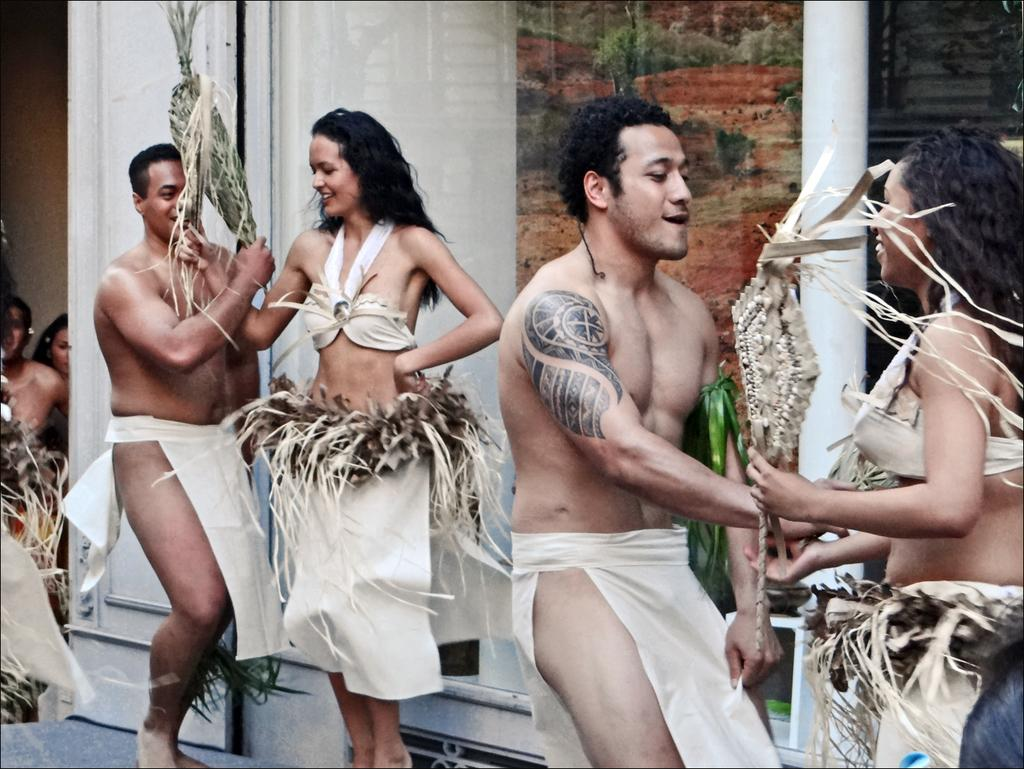How many people are in the image? There is a group of persons in the image. What are the persons wearing? The persons are wearing costumes. What are the persons holding in their hands? The persons are holding objects in their hands. Where are the persons standing? The group is standing on the floor. What can be seen in the background of the image? There is a building and a pillar in the background of the image. What type of offer is being made by the persons in the image? There is no indication in the image that the persons are making any offers. Is there a baseball game happening in the image? There is no baseball game or any reference to baseball in the image. 